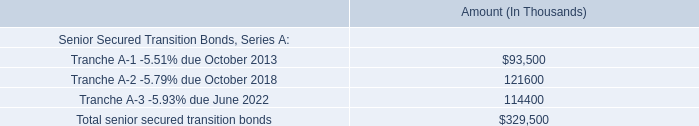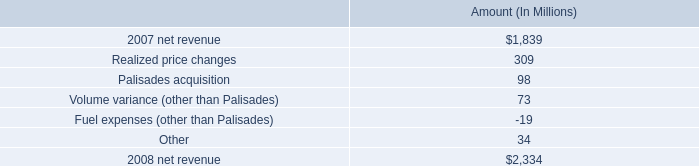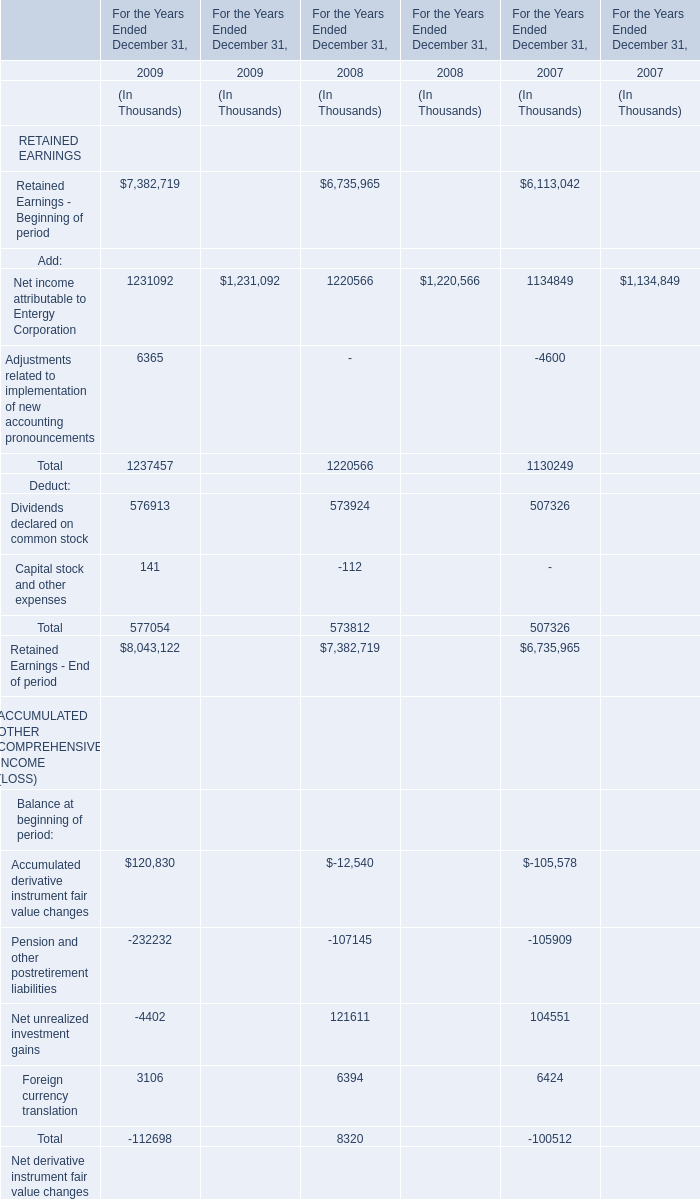what portion of the increase in net revenue from non-utility nuclear is attributed to the change in realized price? 
Computations: (309 / 495)
Answer: 0.62424. 